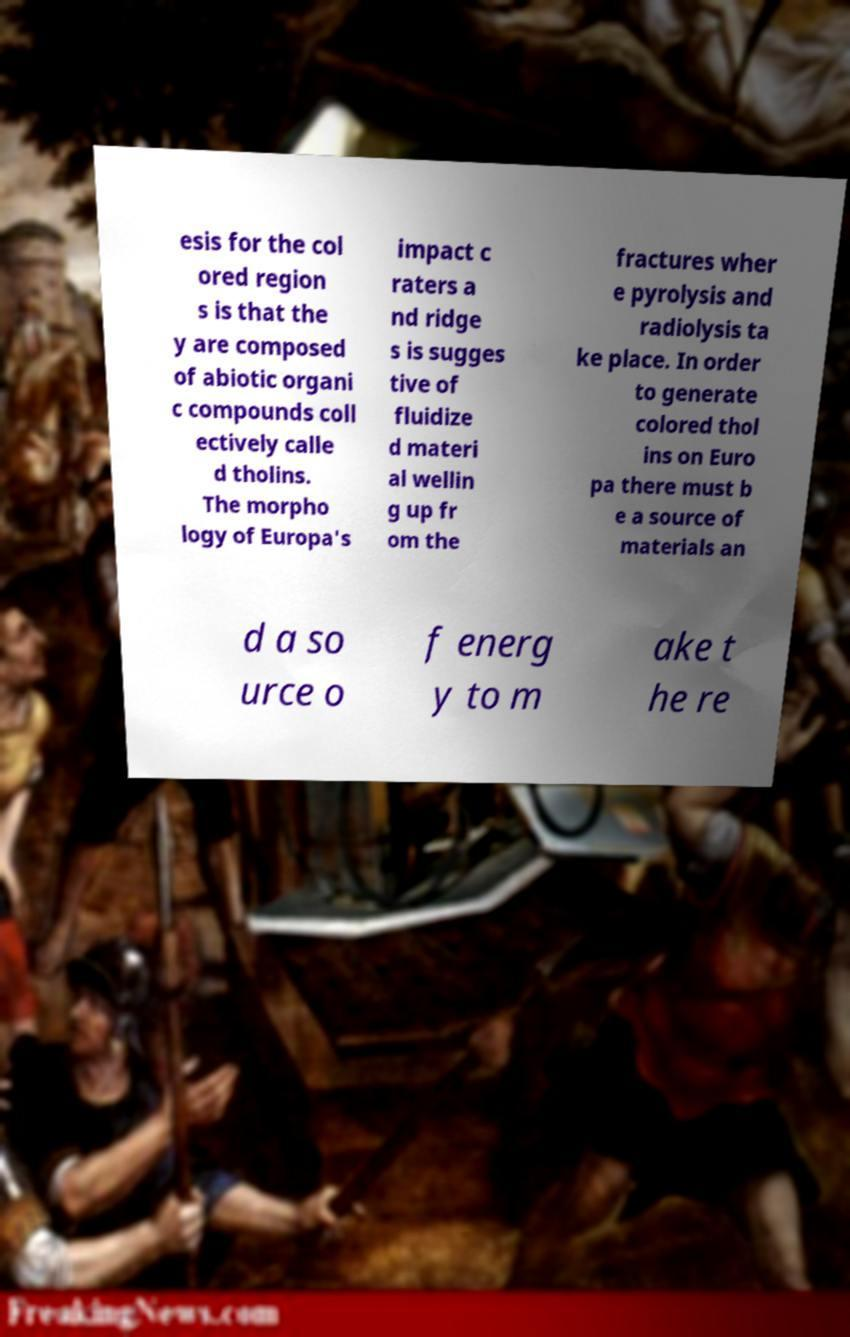Could you assist in decoding the text presented in this image and type it out clearly? esis for the col ored region s is that the y are composed of abiotic organi c compounds coll ectively calle d tholins. The morpho logy of Europa's impact c raters a nd ridge s is sugges tive of fluidize d materi al wellin g up fr om the fractures wher e pyrolysis and radiolysis ta ke place. In order to generate colored thol ins on Euro pa there must b e a source of materials an d a so urce o f energ y to m ake t he re 